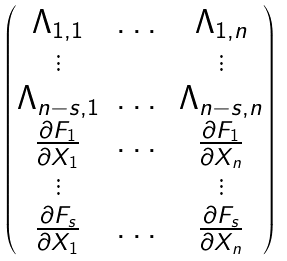<formula> <loc_0><loc_0><loc_500><loc_500>\begin{pmatrix} \Lambda _ { 1 , 1 } & \dots & \Lambda _ { 1 , n } \\ \vdots & & \vdots \\ \Lambda _ { n - s , 1 } & \dots & \Lambda _ { n - s , n } \\ \frac { \partial F _ { 1 } } { \partial X _ { 1 } } & \dots & \frac { \partial F _ { 1 } } { \partial X _ { n } } \\ \vdots & & \vdots \\ \frac { \partial F _ { s } } { \partial X _ { 1 } } & \dots & \frac { \partial F _ { s } } { \partial X _ { n } } \end{pmatrix}</formula> 